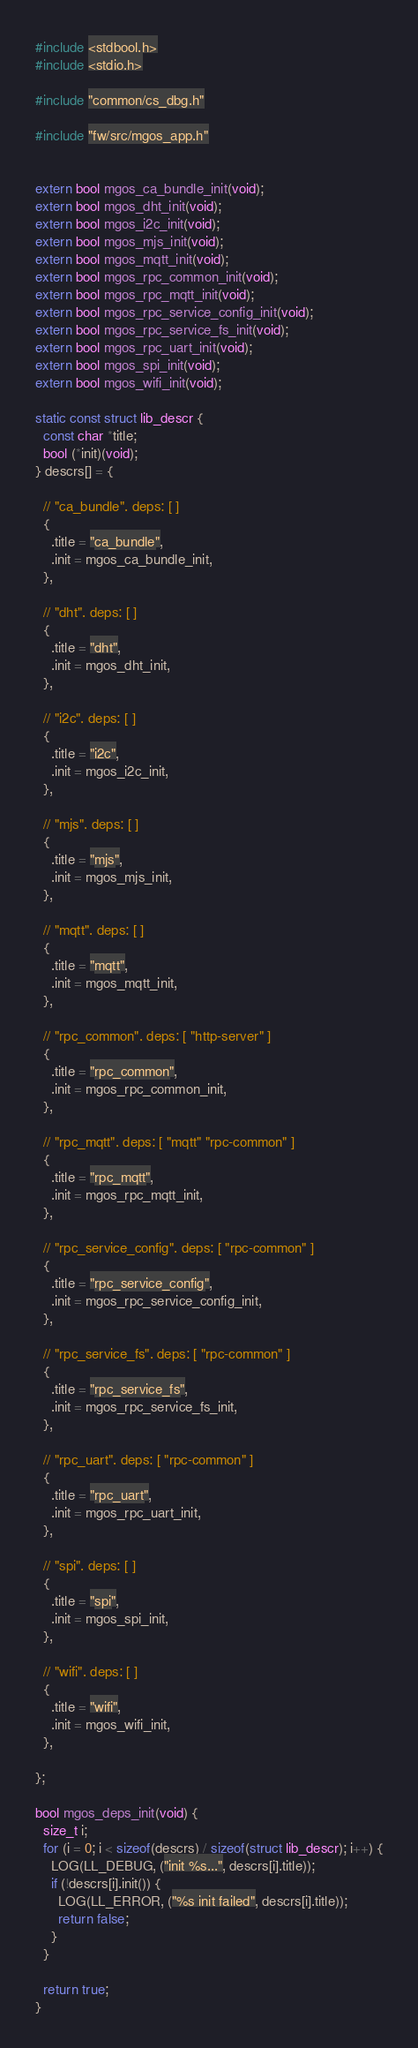Convert code to text. <code><loc_0><loc_0><loc_500><loc_500><_C_>#include <stdbool.h>
#include <stdio.h>

#include "common/cs_dbg.h"

#include "fw/src/mgos_app.h"


extern bool mgos_ca_bundle_init(void);
extern bool mgos_dht_init(void);
extern bool mgos_i2c_init(void);
extern bool mgos_mjs_init(void);
extern bool mgos_mqtt_init(void);
extern bool mgos_rpc_common_init(void);
extern bool mgos_rpc_mqtt_init(void);
extern bool mgos_rpc_service_config_init(void);
extern bool mgos_rpc_service_fs_init(void);
extern bool mgos_rpc_uart_init(void);
extern bool mgos_spi_init(void);
extern bool mgos_wifi_init(void);

static const struct lib_descr {
  const char *title;
  bool (*init)(void);
} descrs[] = {

  // "ca_bundle". deps: [ ]
  {
    .title = "ca_bundle",
    .init = mgos_ca_bundle_init,
  },

  // "dht". deps: [ ]
  {
    .title = "dht",
    .init = mgos_dht_init,
  },

  // "i2c". deps: [ ]
  {
    .title = "i2c",
    .init = mgos_i2c_init,
  },

  // "mjs". deps: [ ]
  {
    .title = "mjs",
    .init = mgos_mjs_init,
  },

  // "mqtt". deps: [ ]
  {
    .title = "mqtt",
    .init = mgos_mqtt_init,
  },

  // "rpc_common". deps: [ "http-server" ]
  {
    .title = "rpc_common",
    .init = mgos_rpc_common_init,
  },

  // "rpc_mqtt". deps: [ "mqtt" "rpc-common" ]
  {
    .title = "rpc_mqtt",
    .init = mgos_rpc_mqtt_init,
  },

  // "rpc_service_config". deps: [ "rpc-common" ]
  {
    .title = "rpc_service_config",
    .init = mgos_rpc_service_config_init,
  },

  // "rpc_service_fs". deps: [ "rpc-common" ]
  {
    .title = "rpc_service_fs",
    .init = mgos_rpc_service_fs_init,
  },

  // "rpc_uart". deps: [ "rpc-common" ]
  {
    .title = "rpc_uart",
    .init = mgos_rpc_uart_init,
  },

  // "spi". deps: [ ]
  {
    .title = "spi",
    .init = mgos_spi_init,
  },

  // "wifi". deps: [ ]
  {
    .title = "wifi",
    .init = mgos_wifi_init,
  },

};

bool mgos_deps_init(void) {
  size_t i;
  for (i = 0; i < sizeof(descrs) / sizeof(struct lib_descr); i++) {
    LOG(LL_DEBUG, ("init %s...", descrs[i].title));
    if (!descrs[i].init()) {
      LOG(LL_ERROR, ("%s init failed", descrs[i].title));
      return false;
    }
  }

  return true;
}
</code> 